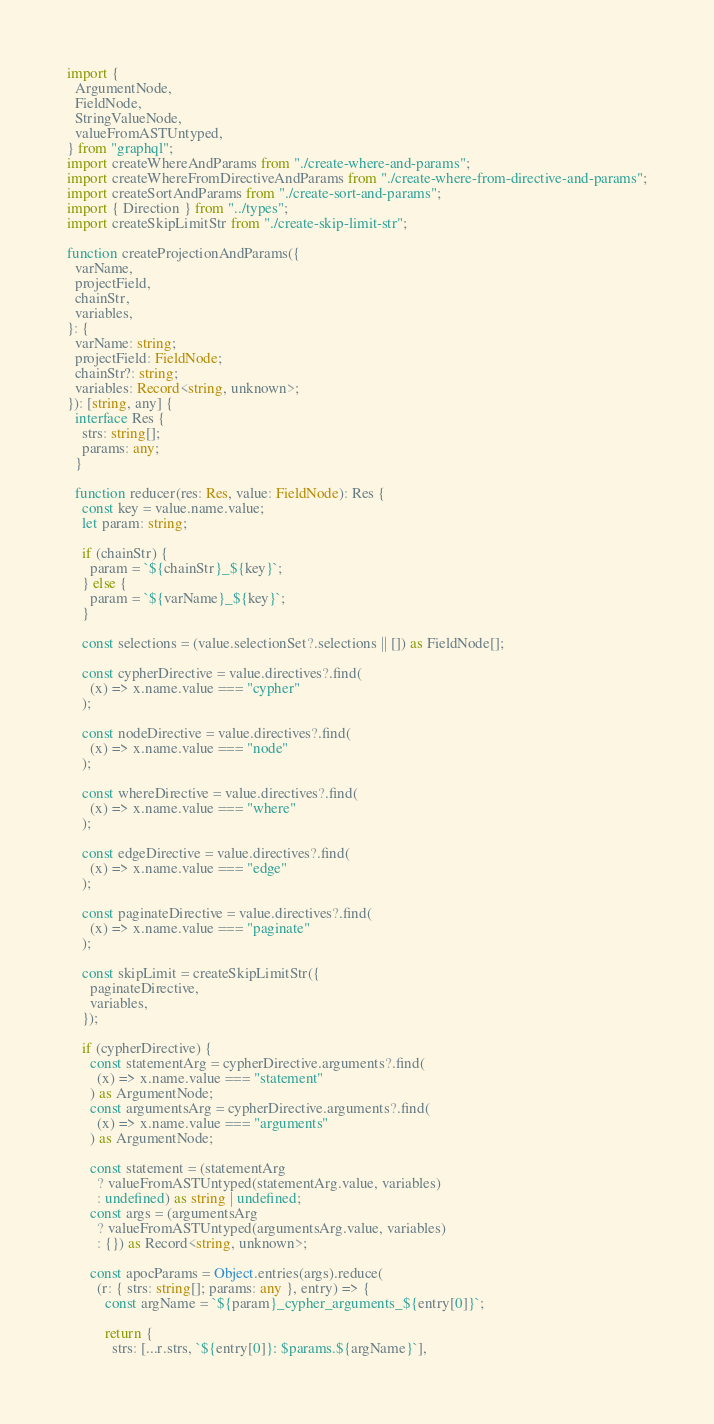Convert code to text. <code><loc_0><loc_0><loc_500><loc_500><_TypeScript_>import {
  ArgumentNode,
  FieldNode,
  StringValueNode,
  valueFromASTUntyped,
} from "graphql";
import createWhereAndParams from "./create-where-and-params";
import createWhereFromDirectiveAndParams from "./create-where-from-directive-and-params";
import createSortAndParams from "./create-sort-and-params";
import { Direction } from "../types";
import createSkipLimitStr from "./create-skip-limit-str";

function createProjectionAndParams({
  varName,
  projectField,
  chainStr,
  variables,
}: {
  varName: string;
  projectField: FieldNode;
  chainStr?: string;
  variables: Record<string, unknown>;
}): [string, any] {
  interface Res {
    strs: string[];
    params: any;
  }

  function reducer(res: Res, value: FieldNode): Res {
    const key = value.name.value;
    let param: string;

    if (chainStr) {
      param = `${chainStr}_${key}`;
    } else {
      param = `${varName}_${key}`;
    }

    const selections = (value.selectionSet?.selections || []) as FieldNode[];

    const cypherDirective = value.directives?.find(
      (x) => x.name.value === "cypher"
    );

    const nodeDirective = value.directives?.find(
      (x) => x.name.value === "node"
    );

    const whereDirective = value.directives?.find(
      (x) => x.name.value === "where"
    );

    const edgeDirective = value.directives?.find(
      (x) => x.name.value === "edge"
    );

    const paginateDirective = value.directives?.find(
      (x) => x.name.value === "paginate"
    );

    const skipLimit = createSkipLimitStr({
      paginateDirective,
      variables,
    });

    if (cypherDirective) {
      const statementArg = cypherDirective.arguments?.find(
        (x) => x.name.value === "statement"
      ) as ArgumentNode;
      const argumentsArg = cypherDirective.arguments?.find(
        (x) => x.name.value === "arguments"
      ) as ArgumentNode;

      const statement = (statementArg
        ? valueFromASTUntyped(statementArg.value, variables)
        : undefined) as string | undefined;
      const args = (argumentsArg
        ? valueFromASTUntyped(argumentsArg.value, variables)
        : {}) as Record<string, unknown>;

      const apocParams = Object.entries(args).reduce(
        (r: { strs: string[]; params: any }, entry) => {
          const argName = `${param}_cypher_arguments_${entry[0]}`;

          return {
            strs: [...r.strs, `${entry[0]}: $params.${argName}`],</code> 